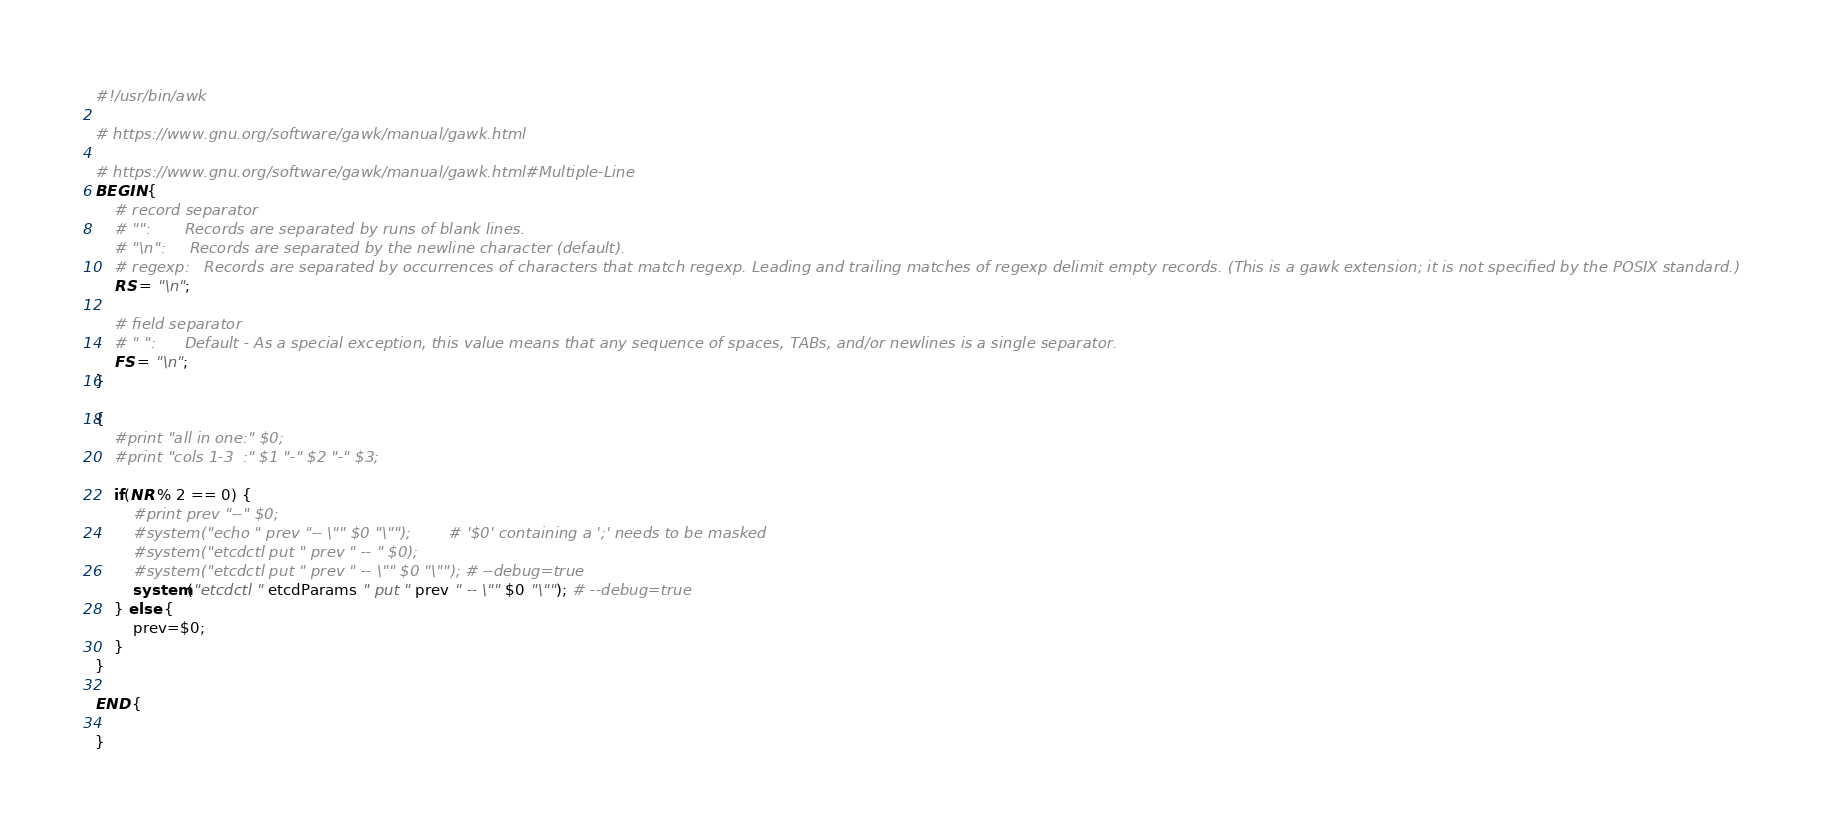Convert code to text. <code><loc_0><loc_0><loc_500><loc_500><_Awk_>#!/usr/bin/awk

# https://www.gnu.org/software/gawk/manual/gawk.html

# https://www.gnu.org/software/gawk/manual/gawk.html#Multiple-Line
BEGIN {
    # record separator
    # "":       Records are separated by runs of blank lines. 
    # "\n":     Records are separated by the newline character (default).
    # regexp:   Records are separated by occurrences of characters that match regexp. Leading and trailing matches of regexp delimit empty records. (This is a gawk extension; it is not specified by the POSIX standard.)
    RS = "\n";

    # field separator
    # " ":      Default - As a special exception, this value means that any sequence of spaces, TABs, and/or newlines is a single separator.
    FS = "\n";
}

{
    #print "all in one:" $0;
    #print "cols 1-3  :" $1 "-" $2 "-" $3;

    if(NR % 2 == 0) {
        #print prev "--" $0;
        #system("echo " prev "-- \"" $0 "\"");        # '$0' containing a ';' needs to be masked
        #system("etcdctl put " prev " -- " $0);
        #system("etcdctl put " prev " -- \"" $0 "\""); # --debug=true
        system("etcdctl " etcdParams " put " prev " -- \"" $0 "\""); # --debug=true
    } else {
        prev=$0;
    }
}

END {

}
</code> 